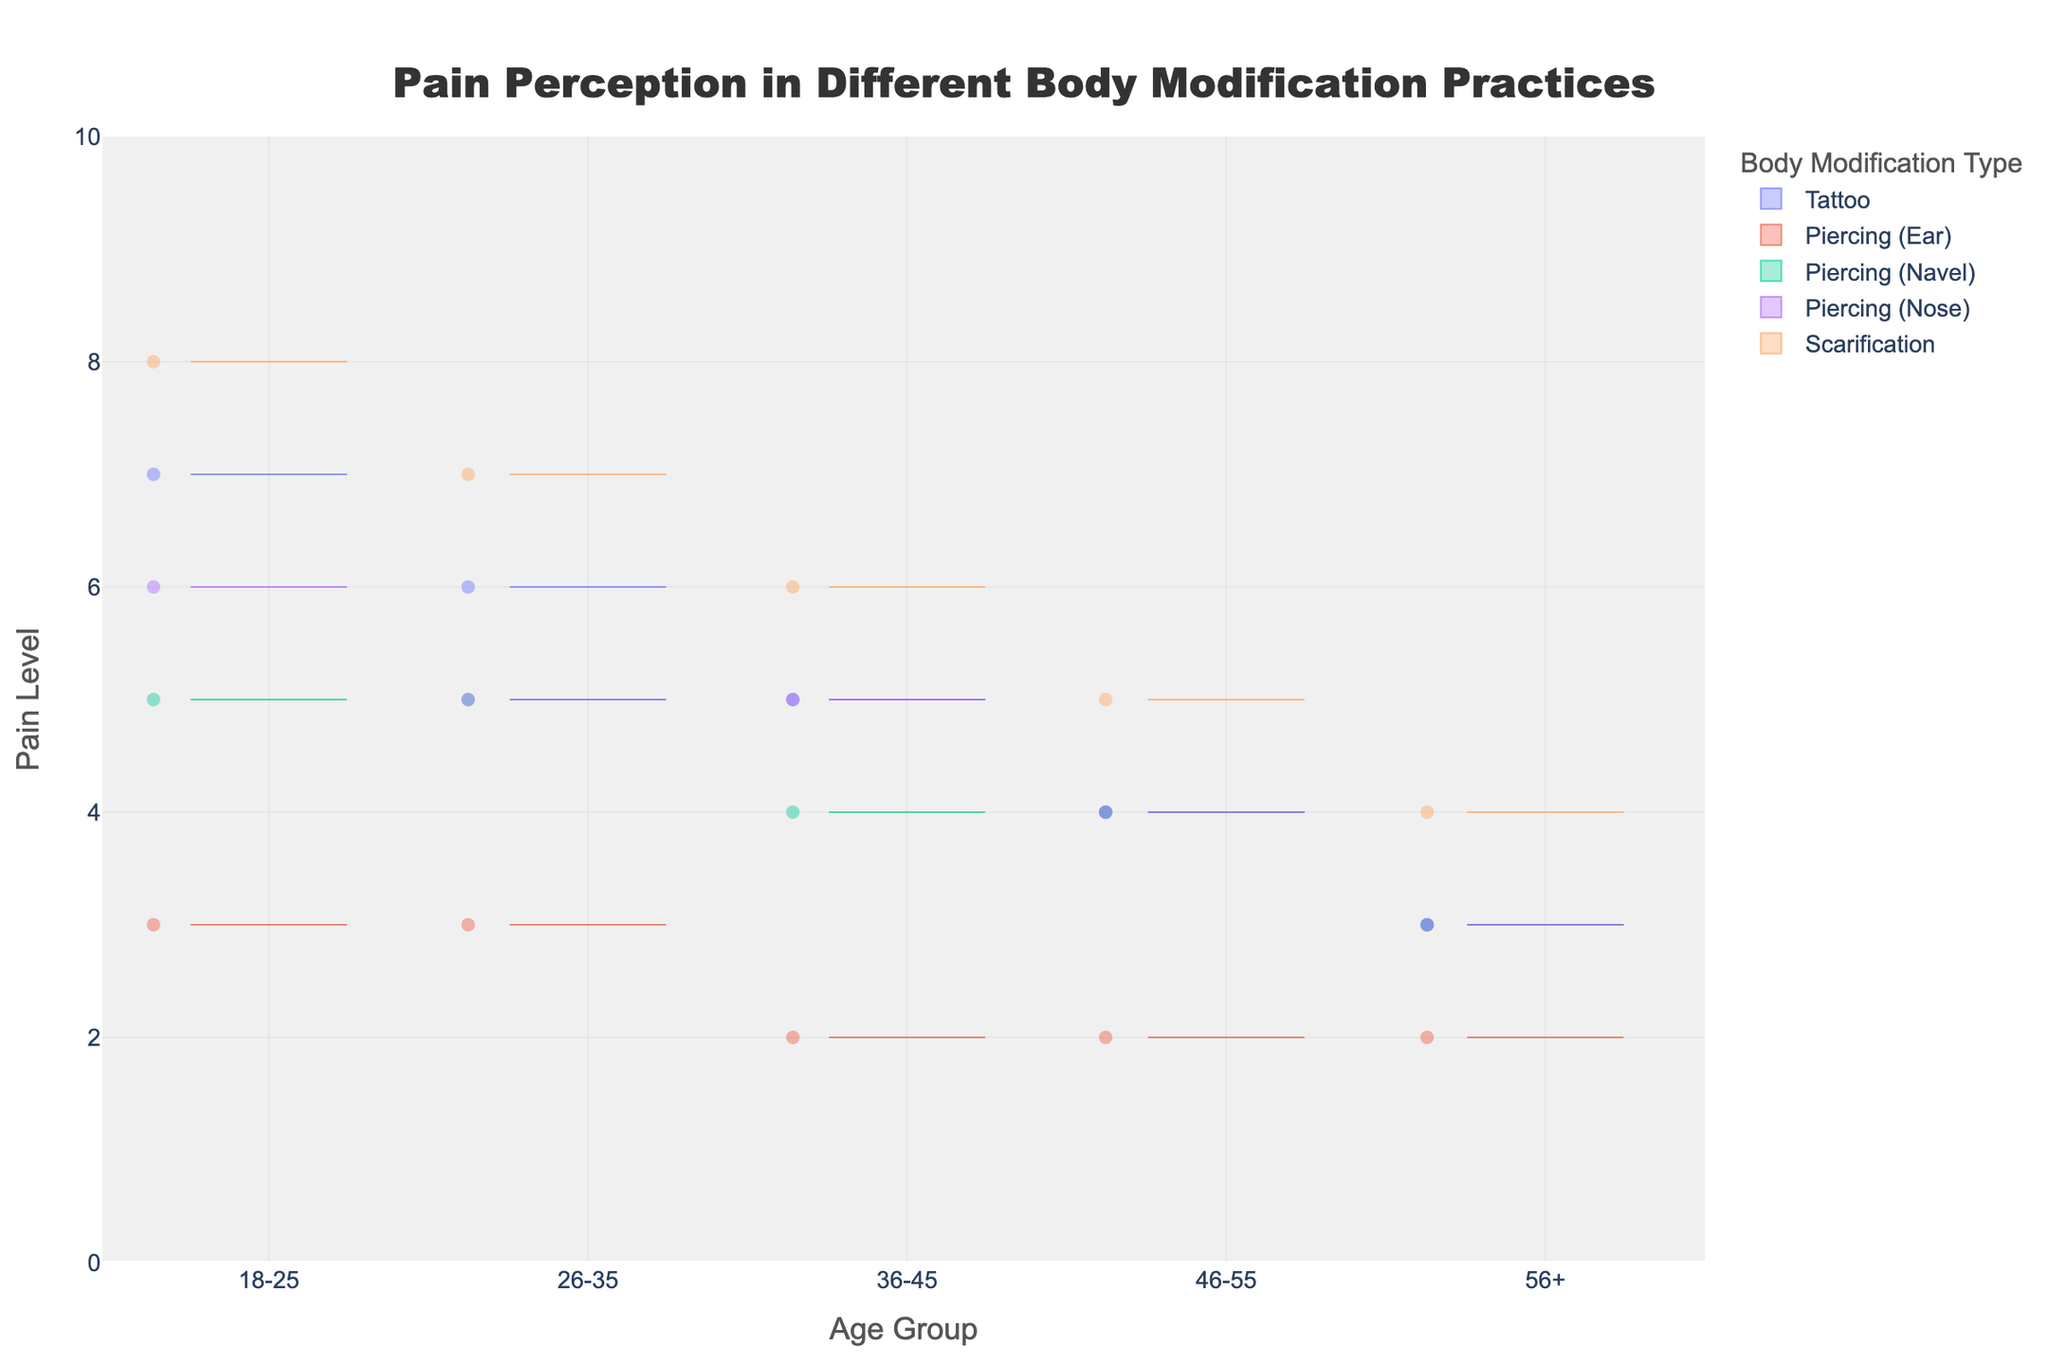What's the title of the figure? The title of the figure is prominently displayed at the top of the chart. It is typically in a larger font size and is descriptive of the content within the chart.
Answer: Pain Perception in Different Body Modification Practices What does the y-axis represent? The y-axis is usually labeled to indicate what type of data it measures. In this case, it measures the perceived pain level.
Answer: Pain Level Which age group reported the highest pain level for scarification? To answer this, look for the highest point on the violin plot for 'Scarification' across different age groups. The plot for the 18-25 age group goes up to a pain level of 8.
Answer: 18-25 Which body modification type shows the least variation in pain level across all age groups? Observe which violin plot is the narrowest and has fewer variations in width across different age groups. 'Piercing (Ear)' appears to have the least variation.
Answer: Piercing (Ear) Between the age groups 36-45 and 46-55, which one shows a lower median pain level for tattoos? Locate the box part of each violin plot for 'Tattoo' in the respective age groups. Compare the median lines (horizontal lines within the boxes). The median line for the 46-55 age group is lower.
Answer: 46-55 What is the general trend in pain perception for tattoos as age increases? Examine the violin plots for 'Tattoo' across different age groups. Notice the general position of the plots. The pain level for tattoos tends to decrease as age increases.
Answer: Decreases Which body modification type has the widest spread of pain levels in the 18-25 age group? Look at the width and spread of the violin plots for each body modification type in the 18-25 age group. 'Scarification' has the widest spread.
Answer: Scarification What is the mean pain level for piercings in the nose for the 26-35 age group? Find the plot for 'Piercing (Nose)' in the 26-35 age group and note the mean line, which is usually displayed as a thicker line. The mean pain level is 5.
Answer: 5 Compare the pain level variability for scarification between the 26-35 and 56+ age groups. Which one is more variable? Determine the variability by comparing the width of the violin plots for 'Scarification' in both age groups. The 26-35 age group shows more variability with a wider plot.
Answer: 26-35 What is the range of pain levels observed for piercing the navel in the 46-55 age group? Look at the vertical span of the violin plot for 'Piercing (Navel)' in the 46-55 age group. The pain levels range from 4 to 4.
Answer: 4 to 4 